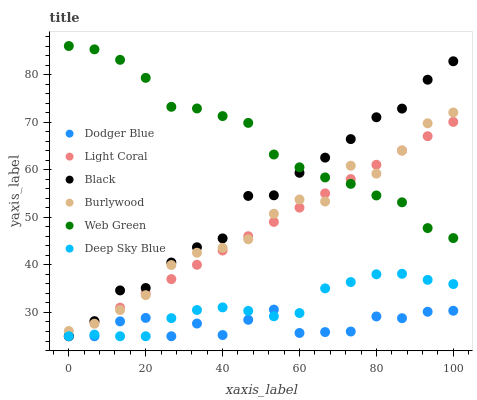Does Dodger Blue have the minimum area under the curve?
Answer yes or no. Yes. Does Web Green have the maximum area under the curve?
Answer yes or no. Yes. Does Light Coral have the minimum area under the curve?
Answer yes or no. No. Does Light Coral have the maximum area under the curve?
Answer yes or no. No. Is Light Coral the smoothest?
Answer yes or no. Yes. Is Dodger Blue the roughest?
Answer yes or no. Yes. Is Web Green the smoothest?
Answer yes or no. No. Is Web Green the roughest?
Answer yes or no. No. Does Light Coral have the lowest value?
Answer yes or no. Yes. Does Web Green have the lowest value?
Answer yes or no. No. Does Web Green have the highest value?
Answer yes or no. Yes. Does Light Coral have the highest value?
Answer yes or no. No. Is Dodger Blue less than Web Green?
Answer yes or no. Yes. Is Web Green greater than Deep Sky Blue?
Answer yes or no. Yes. Does Black intersect Web Green?
Answer yes or no. Yes. Is Black less than Web Green?
Answer yes or no. No. Is Black greater than Web Green?
Answer yes or no. No. Does Dodger Blue intersect Web Green?
Answer yes or no. No. 